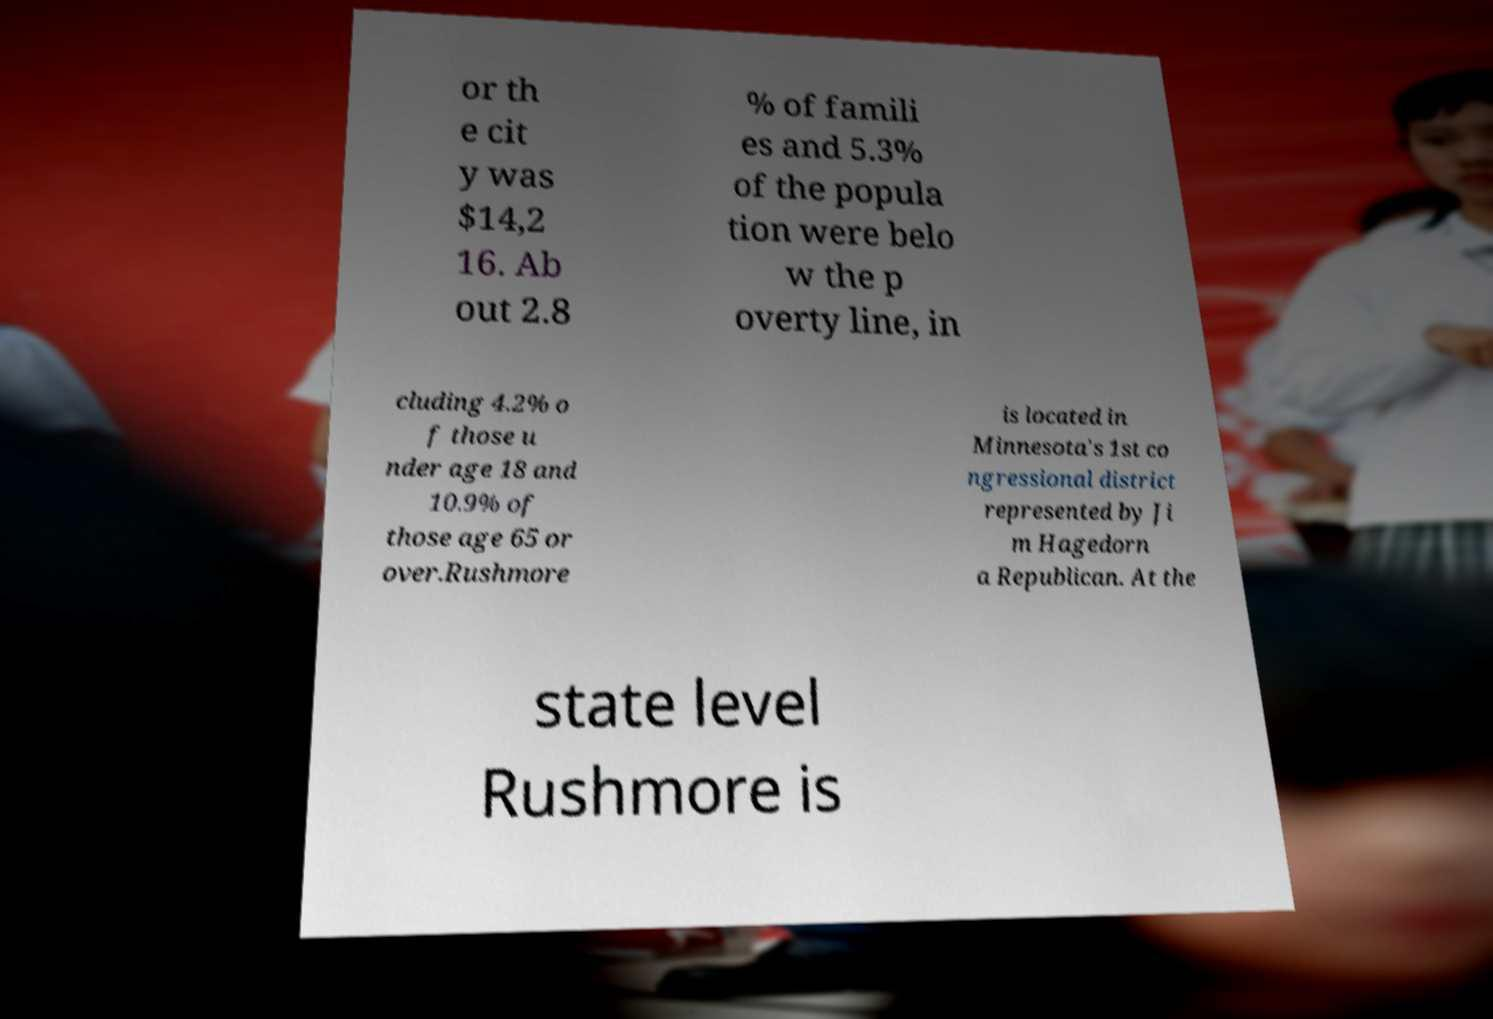Please read and relay the text visible in this image. What does it say? or th e cit y was $14,2 16. Ab out 2.8 % of famili es and 5.3% of the popula tion were belo w the p overty line, in cluding 4.2% o f those u nder age 18 and 10.9% of those age 65 or over.Rushmore is located in Minnesota's 1st co ngressional district represented by Ji m Hagedorn a Republican. At the state level Rushmore is 